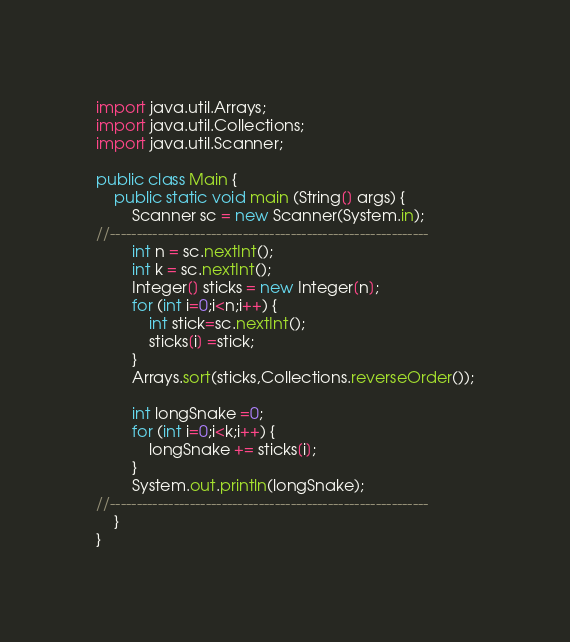<code> <loc_0><loc_0><loc_500><loc_500><_Java_>import java.util.Arrays;
import java.util.Collections;
import java.util.Scanner;

public class Main {
	public static void main (String[] args) {
		Scanner sc = new Scanner(System.in);
//------------------------------------------------------------
		int n = sc.nextInt();
		int k = sc.nextInt();
		Integer[] sticks = new Integer[n];
		for (int i=0;i<n;i++) {
			int stick=sc.nextInt();
			sticks[i] =stick;
		}
		Arrays.sort(sticks,Collections.reverseOrder());

		int longSnake =0;
		for (int i=0;i<k;i++) {
			longSnake += sticks[i];
		}
		System.out.println(longSnake);
//------------------------------------------------------------
	}
}</code> 